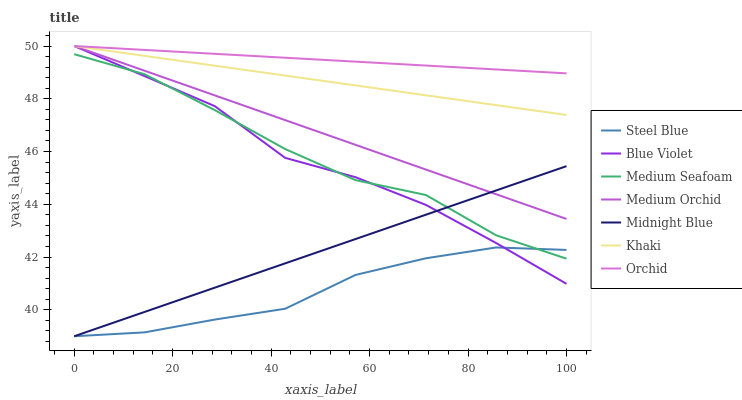Does Steel Blue have the minimum area under the curve?
Answer yes or no. Yes. Does Orchid have the maximum area under the curve?
Answer yes or no. Yes. Does Midnight Blue have the minimum area under the curve?
Answer yes or no. No. Does Midnight Blue have the maximum area under the curve?
Answer yes or no. No. Is Khaki the smoothest?
Answer yes or no. Yes. Is Medium Seafoam the roughest?
Answer yes or no. Yes. Is Midnight Blue the smoothest?
Answer yes or no. No. Is Midnight Blue the roughest?
Answer yes or no. No. Does Midnight Blue have the lowest value?
Answer yes or no. Yes. Does Medium Orchid have the lowest value?
Answer yes or no. No. Does Orchid have the highest value?
Answer yes or no. Yes. Does Midnight Blue have the highest value?
Answer yes or no. No. Is Midnight Blue less than Khaki?
Answer yes or no. Yes. Is Khaki greater than Midnight Blue?
Answer yes or no. Yes. Does Orchid intersect Medium Orchid?
Answer yes or no. Yes. Is Orchid less than Medium Orchid?
Answer yes or no. No. Is Orchid greater than Medium Orchid?
Answer yes or no. No. Does Midnight Blue intersect Khaki?
Answer yes or no. No. 